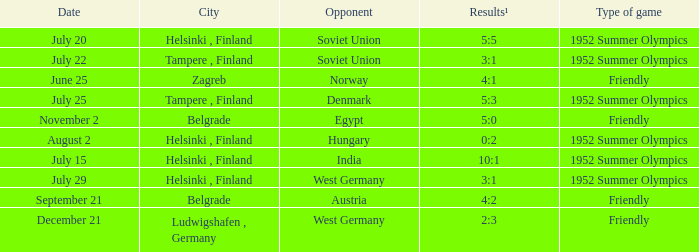With a "game of friendly" type, held in belgrade on november 2, what were the final scores? 5:0. 